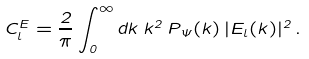<formula> <loc_0><loc_0><loc_500><loc_500>C _ { l } ^ { E } = \frac { 2 } { \pi } \int _ { 0 } ^ { \infty } d k \, k ^ { 2 } \, P _ { \Psi } ( k ) \, | E _ { l } ( k ) | ^ { 2 } \, .</formula> 